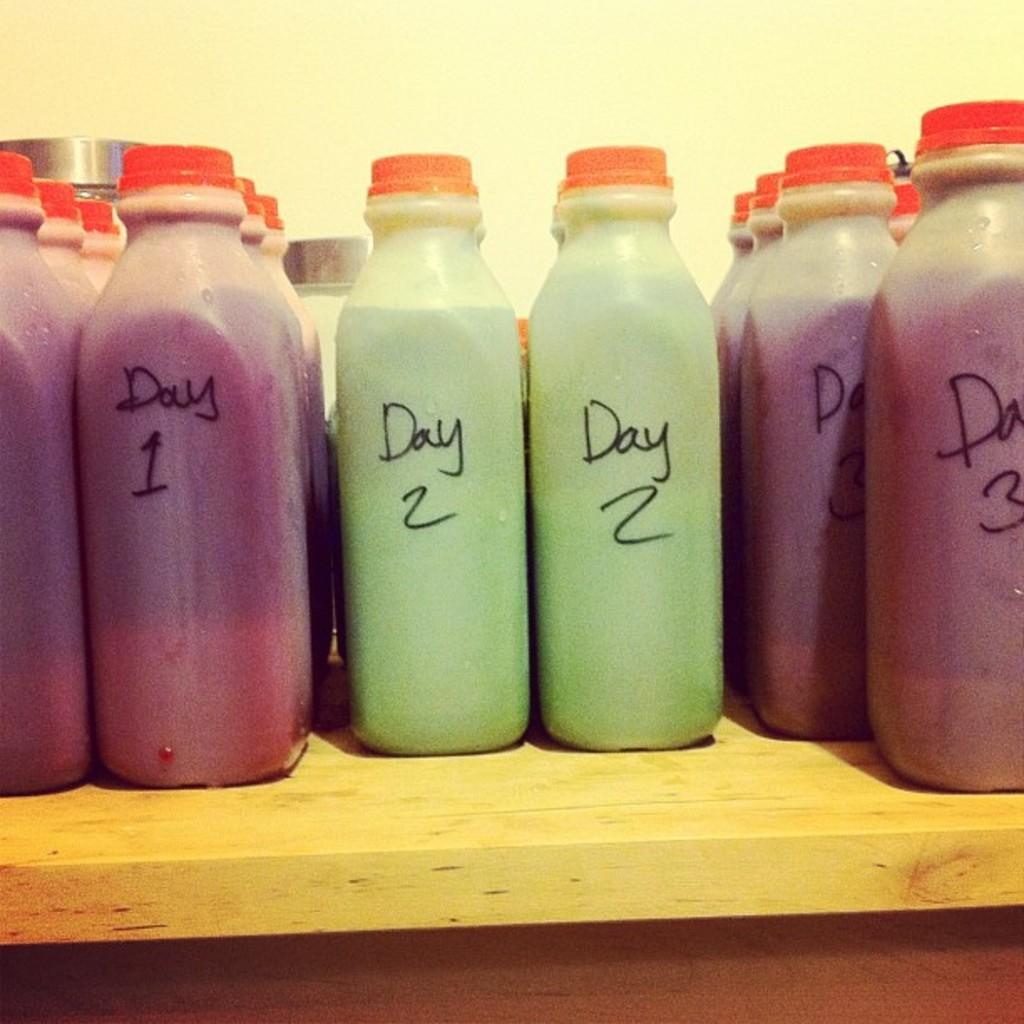What is the same word on each bottle?
Provide a short and direct response. Day. 